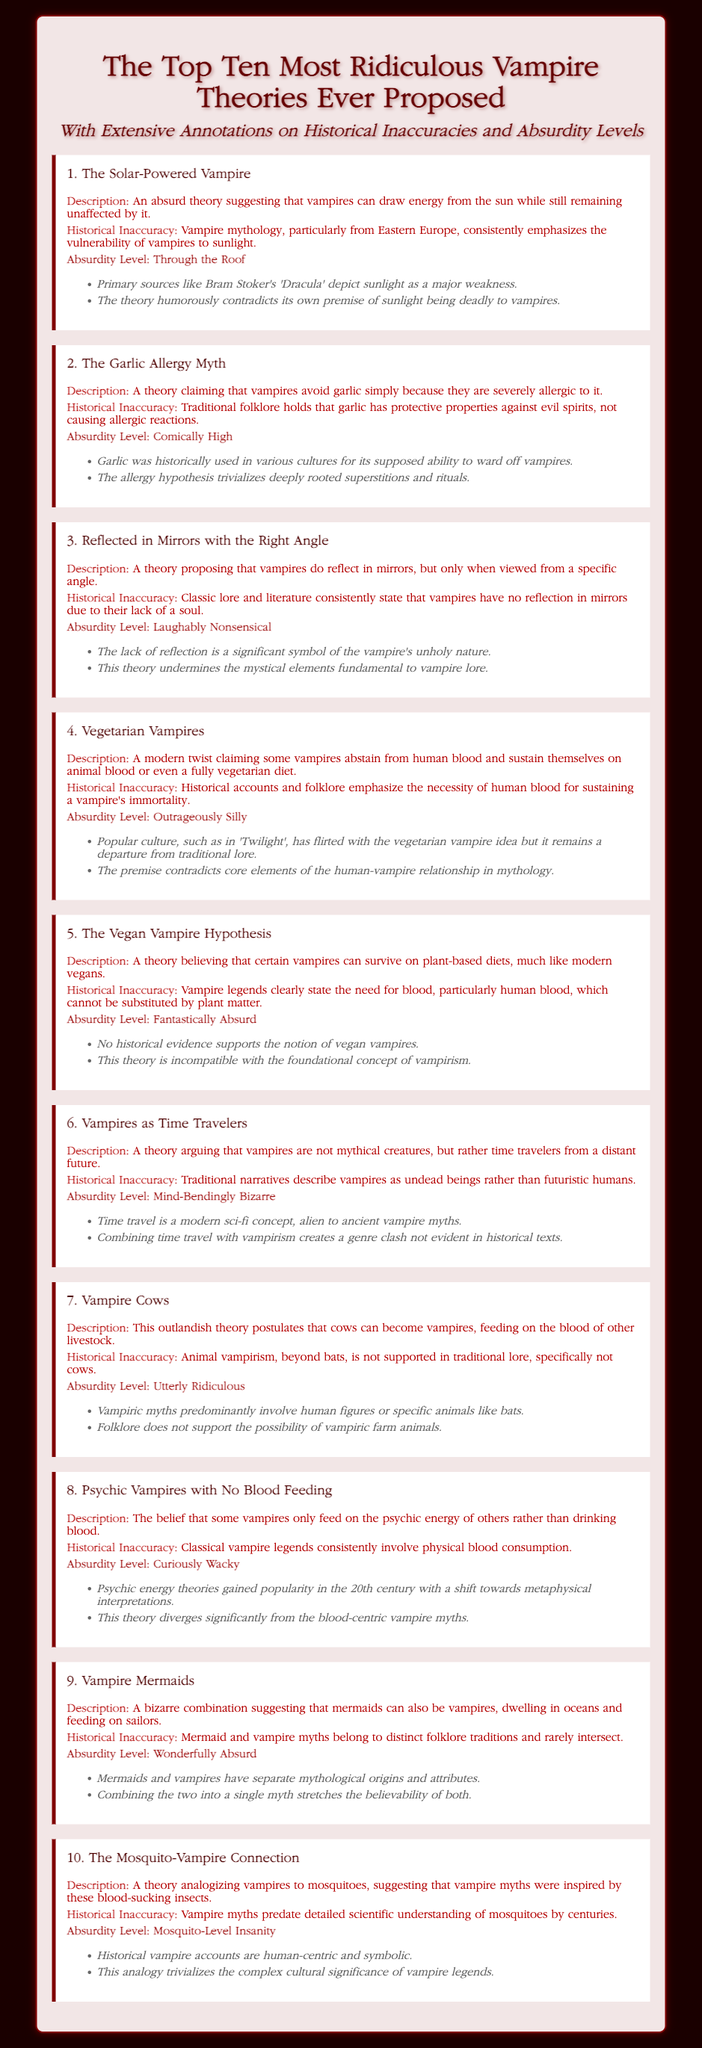What is the title of the document? The title is specified in the `<title>` tag, which states "Top Ten Ridiculous Vampire Theories".
Answer: Top Ten Ridiculous Vampire Theories How many vampire theories are listed in the document? The document states there are "Top Ten" theories, indicating the total count as ten.
Answer: Ten What is the absurdity level of theory number one? The absurdity level for the first theory is mentioned as "Through the Roof".
Answer: Through the Roof Which vampire theory claims that vampires feed on psychic energy? The description for the relevant theory specifically names "Psychic Vampires with No Blood Feeding" as the one that feeds on psychic energy.
Answer: Psychic Vampires with No Blood Feeding What historical inaccuracy is associated with the Vegan Vampire Hypothesis? The historical inaccuracy states that "Vampire legends clearly state the need for blood".
Answer: Need for blood What color is the background of the document? The background color is set in the CSS as "#1a0000", which is a dark shade.
Answer: Dark shade Which theory involves cows? The theory specifically titled "Vampire Cows" discusses the idea of cows becoming vampires.
Answer: Vampire Cows What do most vampire theories in the document focus on? The majority of theories center around different interpretations and absurd concepts about vampires and their diet or characteristics.
Answer: Vampires and their diet 